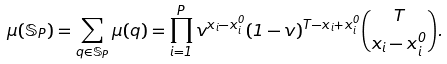Convert formula to latex. <formula><loc_0><loc_0><loc_500><loc_500>\mu ( { \mathbb { S } } _ { P } ) = \sum _ { q \in { \mathbb { S } } _ { P } } \mu ( q ) = \prod _ { i = 1 } ^ { P } v ^ { x _ { i } - x ^ { 0 } _ { i } } ( 1 - v ) ^ { T - x _ { i } + x _ { i } ^ { 0 } } \binom { T } { x _ { i } - x ^ { 0 } _ { i } } .</formula> 